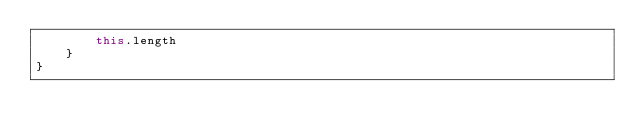<code> <loc_0><loc_0><loc_500><loc_500><_Kotlin_>        this.length
    }
}</code> 